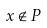<formula> <loc_0><loc_0><loc_500><loc_500>x \notin P</formula> 